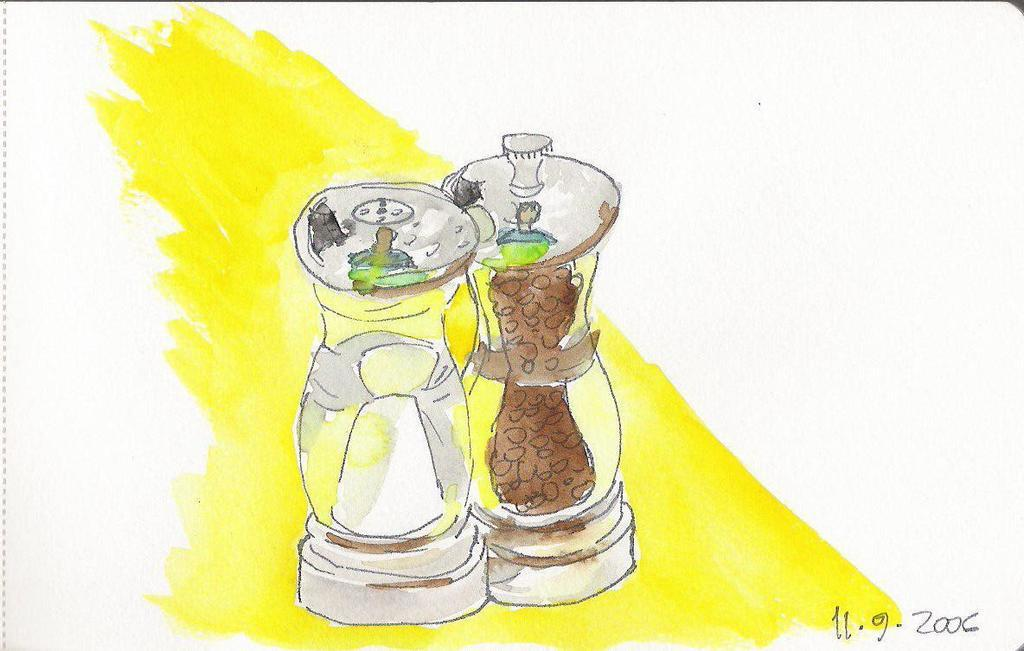<image>
Describe the image concisely. A picture with salt and pepper drawn and dated September 2006. 